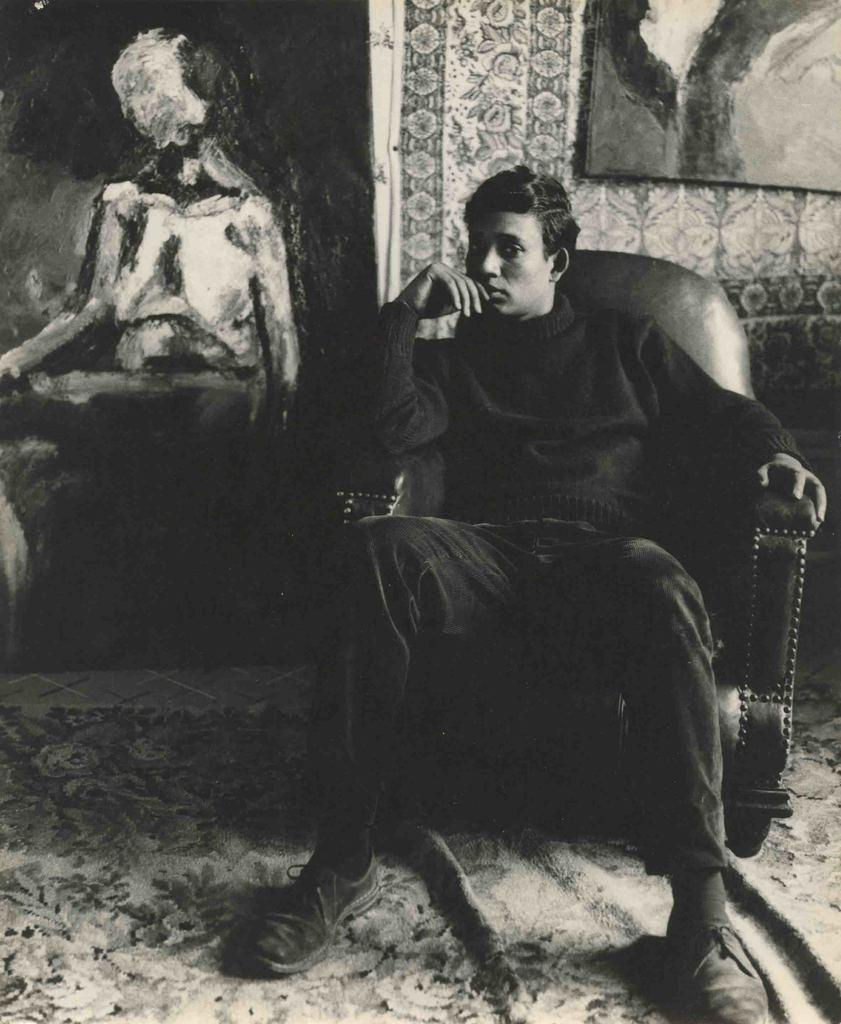Who or what is the main subject in the picture? There is a person in the picture. What is the person doing in the image? The person is sitting in a chair. What can be seen on the wall in the background? There is a painting on the wall in the background. What type of floor covering is visible in the image? There is a carpet on the floor. What type of van is parked outside the window in the image? There is no van visible in the image; it only shows a person sitting in a chair with a painting on the wall in the background and a carpet on the floor. 